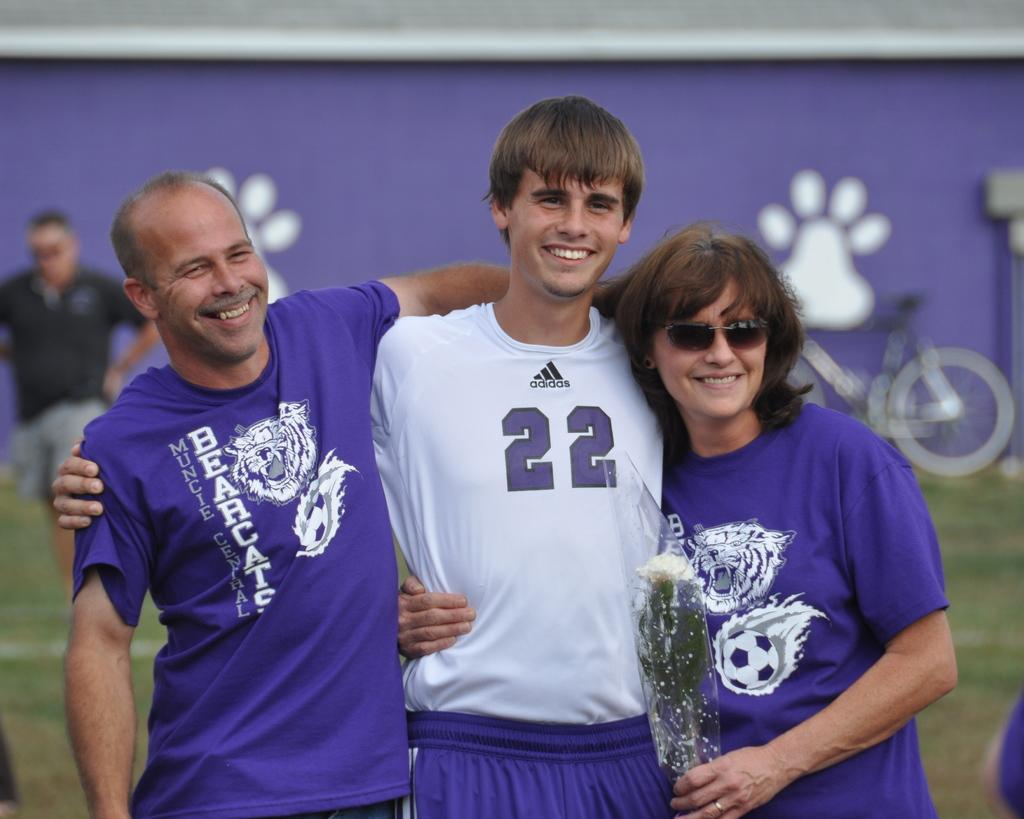How many people are in the image? There are three persons standing in the middle of the image. What are the people doing in the image? The persons are smiling. What can be seen in the background of the image? There is grass, bicycles, and a banner visible in the background. How is the background of the image depicted? The background of the image is blurred. What type of sea creature can be seen in the pocket of one of the persons in the image? There is no sea creature present in the image, nor is there any indication that any of the persons have a pocket with a creature in it. 